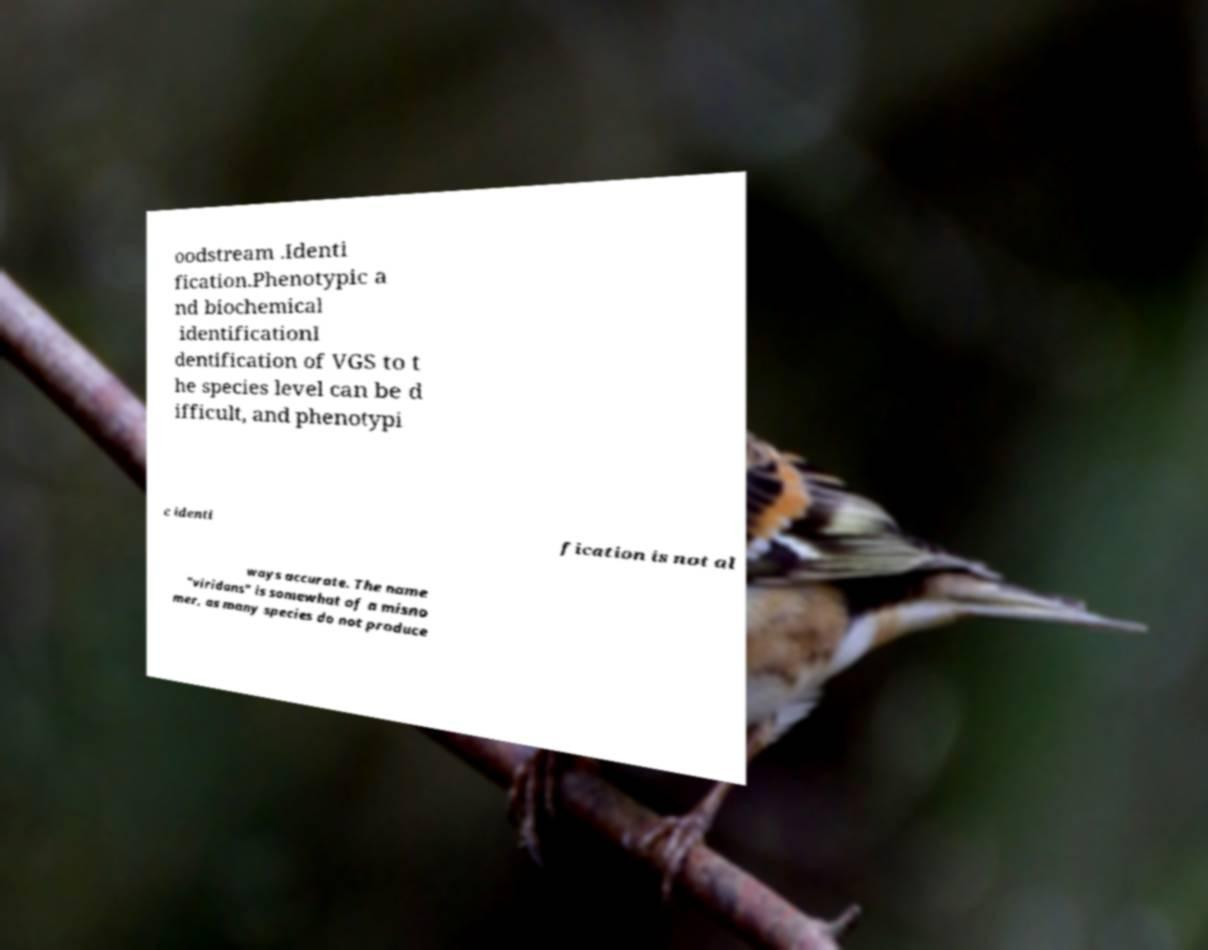Please read and relay the text visible in this image. What does it say? oodstream .Identi fication.Phenotypic a nd biochemical identificationI dentification of VGS to t he species level can be d ifficult, and phenotypi c identi fication is not al ways accurate. The name "viridans" is somewhat of a misno mer, as many species do not produce 